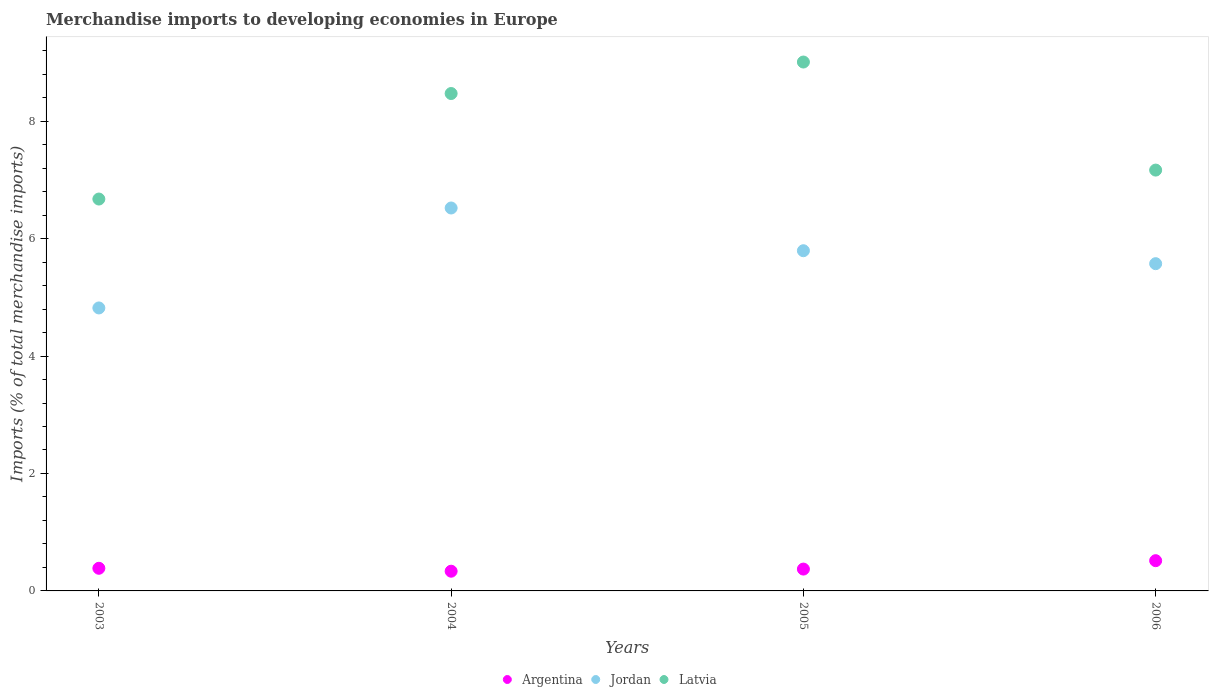What is the percentage total merchandise imports in Latvia in 2004?
Offer a very short reply. 8.47. Across all years, what is the maximum percentage total merchandise imports in Argentina?
Provide a short and direct response. 0.52. Across all years, what is the minimum percentage total merchandise imports in Argentina?
Offer a terse response. 0.34. In which year was the percentage total merchandise imports in Latvia maximum?
Your answer should be very brief. 2005. What is the total percentage total merchandise imports in Argentina in the graph?
Provide a succinct answer. 1.61. What is the difference between the percentage total merchandise imports in Jordan in 2004 and that in 2005?
Your answer should be very brief. 0.73. What is the difference between the percentage total merchandise imports in Argentina in 2004 and the percentage total merchandise imports in Jordan in 2005?
Offer a terse response. -5.46. What is the average percentage total merchandise imports in Latvia per year?
Provide a short and direct response. 7.83. In the year 2004, what is the difference between the percentage total merchandise imports in Latvia and percentage total merchandise imports in Jordan?
Your answer should be compact. 1.95. In how many years, is the percentage total merchandise imports in Latvia greater than 3.6 %?
Offer a very short reply. 4. What is the ratio of the percentage total merchandise imports in Argentina in 2004 to that in 2006?
Give a very brief answer. 0.65. Is the difference between the percentage total merchandise imports in Latvia in 2003 and 2005 greater than the difference between the percentage total merchandise imports in Jordan in 2003 and 2005?
Offer a terse response. No. What is the difference between the highest and the second highest percentage total merchandise imports in Argentina?
Make the answer very short. 0.13. What is the difference between the highest and the lowest percentage total merchandise imports in Jordan?
Keep it short and to the point. 1.7. Does the percentage total merchandise imports in Jordan monotonically increase over the years?
Your answer should be compact. No. Is the percentage total merchandise imports in Argentina strictly greater than the percentage total merchandise imports in Latvia over the years?
Keep it short and to the point. No. Is the percentage total merchandise imports in Jordan strictly less than the percentage total merchandise imports in Argentina over the years?
Provide a short and direct response. No. How many dotlines are there?
Make the answer very short. 3. How many years are there in the graph?
Offer a terse response. 4. What is the difference between two consecutive major ticks on the Y-axis?
Make the answer very short. 2. Are the values on the major ticks of Y-axis written in scientific E-notation?
Offer a terse response. No. Where does the legend appear in the graph?
Offer a terse response. Bottom center. How are the legend labels stacked?
Provide a succinct answer. Horizontal. What is the title of the graph?
Provide a succinct answer. Merchandise imports to developing economies in Europe. Does "Fiji" appear as one of the legend labels in the graph?
Offer a terse response. No. What is the label or title of the X-axis?
Make the answer very short. Years. What is the label or title of the Y-axis?
Make the answer very short. Imports (% of total merchandise imports). What is the Imports (% of total merchandise imports) in Argentina in 2003?
Give a very brief answer. 0.39. What is the Imports (% of total merchandise imports) in Jordan in 2003?
Your answer should be very brief. 4.82. What is the Imports (% of total merchandise imports) in Latvia in 2003?
Provide a succinct answer. 6.67. What is the Imports (% of total merchandise imports) of Argentina in 2004?
Keep it short and to the point. 0.34. What is the Imports (% of total merchandise imports) of Jordan in 2004?
Ensure brevity in your answer.  6.52. What is the Imports (% of total merchandise imports) of Latvia in 2004?
Provide a succinct answer. 8.47. What is the Imports (% of total merchandise imports) in Argentina in 2005?
Make the answer very short. 0.37. What is the Imports (% of total merchandise imports) of Jordan in 2005?
Your response must be concise. 5.79. What is the Imports (% of total merchandise imports) of Latvia in 2005?
Your response must be concise. 9.01. What is the Imports (% of total merchandise imports) in Argentina in 2006?
Provide a succinct answer. 0.52. What is the Imports (% of total merchandise imports) in Jordan in 2006?
Make the answer very short. 5.57. What is the Imports (% of total merchandise imports) in Latvia in 2006?
Ensure brevity in your answer.  7.17. Across all years, what is the maximum Imports (% of total merchandise imports) in Argentina?
Your answer should be compact. 0.52. Across all years, what is the maximum Imports (% of total merchandise imports) of Jordan?
Provide a short and direct response. 6.52. Across all years, what is the maximum Imports (% of total merchandise imports) of Latvia?
Give a very brief answer. 9.01. Across all years, what is the minimum Imports (% of total merchandise imports) in Argentina?
Give a very brief answer. 0.34. Across all years, what is the minimum Imports (% of total merchandise imports) of Jordan?
Give a very brief answer. 4.82. Across all years, what is the minimum Imports (% of total merchandise imports) of Latvia?
Give a very brief answer. 6.67. What is the total Imports (% of total merchandise imports) in Argentina in the graph?
Keep it short and to the point. 1.61. What is the total Imports (% of total merchandise imports) in Jordan in the graph?
Keep it short and to the point. 22.71. What is the total Imports (% of total merchandise imports) of Latvia in the graph?
Ensure brevity in your answer.  31.32. What is the difference between the Imports (% of total merchandise imports) of Argentina in 2003 and that in 2004?
Offer a very short reply. 0.05. What is the difference between the Imports (% of total merchandise imports) of Jordan in 2003 and that in 2004?
Provide a succinct answer. -1.7. What is the difference between the Imports (% of total merchandise imports) in Latvia in 2003 and that in 2004?
Offer a terse response. -1.8. What is the difference between the Imports (% of total merchandise imports) of Argentina in 2003 and that in 2005?
Ensure brevity in your answer.  0.01. What is the difference between the Imports (% of total merchandise imports) in Jordan in 2003 and that in 2005?
Make the answer very short. -0.97. What is the difference between the Imports (% of total merchandise imports) of Latvia in 2003 and that in 2005?
Give a very brief answer. -2.33. What is the difference between the Imports (% of total merchandise imports) in Argentina in 2003 and that in 2006?
Give a very brief answer. -0.13. What is the difference between the Imports (% of total merchandise imports) of Jordan in 2003 and that in 2006?
Give a very brief answer. -0.75. What is the difference between the Imports (% of total merchandise imports) of Latvia in 2003 and that in 2006?
Make the answer very short. -0.49. What is the difference between the Imports (% of total merchandise imports) of Argentina in 2004 and that in 2005?
Provide a succinct answer. -0.04. What is the difference between the Imports (% of total merchandise imports) in Jordan in 2004 and that in 2005?
Your response must be concise. 0.73. What is the difference between the Imports (% of total merchandise imports) of Latvia in 2004 and that in 2005?
Your answer should be very brief. -0.54. What is the difference between the Imports (% of total merchandise imports) of Argentina in 2004 and that in 2006?
Offer a very short reply. -0.18. What is the difference between the Imports (% of total merchandise imports) of Jordan in 2004 and that in 2006?
Offer a terse response. 0.95. What is the difference between the Imports (% of total merchandise imports) of Latvia in 2004 and that in 2006?
Give a very brief answer. 1.3. What is the difference between the Imports (% of total merchandise imports) in Argentina in 2005 and that in 2006?
Your response must be concise. -0.14. What is the difference between the Imports (% of total merchandise imports) of Jordan in 2005 and that in 2006?
Your answer should be very brief. 0.22. What is the difference between the Imports (% of total merchandise imports) of Latvia in 2005 and that in 2006?
Offer a very short reply. 1.84. What is the difference between the Imports (% of total merchandise imports) of Argentina in 2003 and the Imports (% of total merchandise imports) of Jordan in 2004?
Provide a short and direct response. -6.14. What is the difference between the Imports (% of total merchandise imports) in Argentina in 2003 and the Imports (% of total merchandise imports) in Latvia in 2004?
Your answer should be very brief. -8.09. What is the difference between the Imports (% of total merchandise imports) in Jordan in 2003 and the Imports (% of total merchandise imports) in Latvia in 2004?
Your response must be concise. -3.65. What is the difference between the Imports (% of total merchandise imports) in Argentina in 2003 and the Imports (% of total merchandise imports) in Jordan in 2005?
Offer a very short reply. -5.41. What is the difference between the Imports (% of total merchandise imports) of Argentina in 2003 and the Imports (% of total merchandise imports) of Latvia in 2005?
Keep it short and to the point. -8.62. What is the difference between the Imports (% of total merchandise imports) of Jordan in 2003 and the Imports (% of total merchandise imports) of Latvia in 2005?
Offer a very short reply. -4.19. What is the difference between the Imports (% of total merchandise imports) in Argentina in 2003 and the Imports (% of total merchandise imports) in Jordan in 2006?
Your response must be concise. -5.19. What is the difference between the Imports (% of total merchandise imports) in Argentina in 2003 and the Imports (% of total merchandise imports) in Latvia in 2006?
Provide a short and direct response. -6.78. What is the difference between the Imports (% of total merchandise imports) of Jordan in 2003 and the Imports (% of total merchandise imports) of Latvia in 2006?
Provide a succinct answer. -2.35. What is the difference between the Imports (% of total merchandise imports) in Argentina in 2004 and the Imports (% of total merchandise imports) in Jordan in 2005?
Offer a terse response. -5.46. What is the difference between the Imports (% of total merchandise imports) of Argentina in 2004 and the Imports (% of total merchandise imports) of Latvia in 2005?
Make the answer very short. -8.67. What is the difference between the Imports (% of total merchandise imports) of Jordan in 2004 and the Imports (% of total merchandise imports) of Latvia in 2005?
Provide a succinct answer. -2.49. What is the difference between the Imports (% of total merchandise imports) in Argentina in 2004 and the Imports (% of total merchandise imports) in Jordan in 2006?
Ensure brevity in your answer.  -5.24. What is the difference between the Imports (% of total merchandise imports) of Argentina in 2004 and the Imports (% of total merchandise imports) of Latvia in 2006?
Provide a succinct answer. -6.83. What is the difference between the Imports (% of total merchandise imports) of Jordan in 2004 and the Imports (% of total merchandise imports) of Latvia in 2006?
Offer a very short reply. -0.65. What is the difference between the Imports (% of total merchandise imports) in Argentina in 2005 and the Imports (% of total merchandise imports) in Jordan in 2006?
Keep it short and to the point. -5.2. What is the difference between the Imports (% of total merchandise imports) in Argentina in 2005 and the Imports (% of total merchandise imports) in Latvia in 2006?
Make the answer very short. -6.8. What is the difference between the Imports (% of total merchandise imports) in Jordan in 2005 and the Imports (% of total merchandise imports) in Latvia in 2006?
Your answer should be very brief. -1.37. What is the average Imports (% of total merchandise imports) in Argentina per year?
Offer a terse response. 0.4. What is the average Imports (% of total merchandise imports) of Jordan per year?
Make the answer very short. 5.68. What is the average Imports (% of total merchandise imports) in Latvia per year?
Make the answer very short. 7.83. In the year 2003, what is the difference between the Imports (% of total merchandise imports) of Argentina and Imports (% of total merchandise imports) of Jordan?
Provide a short and direct response. -4.43. In the year 2003, what is the difference between the Imports (% of total merchandise imports) of Argentina and Imports (% of total merchandise imports) of Latvia?
Offer a terse response. -6.29. In the year 2003, what is the difference between the Imports (% of total merchandise imports) in Jordan and Imports (% of total merchandise imports) in Latvia?
Your response must be concise. -1.85. In the year 2004, what is the difference between the Imports (% of total merchandise imports) of Argentina and Imports (% of total merchandise imports) of Jordan?
Your response must be concise. -6.19. In the year 2004, what is the difference between the Imports (% of total merchandise imports) in Argentina and Imports (% of total merchandise imports) in Latvia?
Make the answer very short. -8.14. In the year 2004, what is the difference between the Imports (% of total merchandise imports) of Jordan and Imports (% of total merchandise imports) of Latvia?
Your response must be concise. -1.95. In the year 2005, what is the difference between the Imports (% of total merchandise imports) of Argentina and Imports (% of total merchandise imports) of Jordan?
Your response must be concise. -5.42. In the year 2005, what is the difference between the Imports (% of total merchandise imports) of Argentina and Imports (% of total merchandise imports) of Latvia?
Your response must be concise. -8.64. In the year 2005, what is the difference between the Imports (% of total merchandise imports) of Jordan and Imports (% of total merchandise imports) of Latvia?
Make the answer very short. -3.21. In the year 2006, what is the difference between the Imports (% of total merchandise imports) in Argentina and Imports (% of total merchandise imports) in Jordan?
Make the answer very short. -5.06. In the year 2006, what is the difference between the Imports (% of total merchandise imports) in Argentina and Imports (% of total merchandise imports) in Latvia?
Provide a succinct answer. -6.65. In the year 2006, what is the difference between the Imports (% of total merchandise imports) of Jordan and Imports (% of total merchandise imports) of Latvia?
Ensure brevity in your answer.  -1.59. What is the ratio of the Imports (% of total merchandise imports) of Argentina in 2003 to that in 2004?
Your answer should be compact. 1.15. What is the ratio of the Imports (% of total merchandise imports) in Jordan in 2003 to that in 2004?
Keep it short and to the point. 0.74. What is the ratio of the Imports (% of total merchandise imports) of Latvia in 2003 to that in 2004?
Keep it short and to the point. 0.79. What is the ratio of the Imports (% of total merchandise imports) in Argentina in 2003 to that in 2005?
Your response must be concise. 1.04. What is the ratio of the Imports (% of total merchandise imports) of Jordan in 2003 to that in 2005?
Keep it short and to the point. 0.83. What is the ratio of the Imports (% of total merchandise imports) of Latvia in 2003 to that in 2005?
Make the answer very short. 0.74. What is the ratio of the Imports (% of total merchandise imports) of Argentina in 2003 to that in 2006?
Keep it short and to the point. 0.75. What is the ratio of the Imports (% of total merchandise imports) of Jordan in 2003 to that in 2006?
Give a very brief answer. 0.86. What is the ratio of the Imports (% of total merchandise imports) in Latvia in 2003 to that in 2006?
Your response must be concise. 0.93. What is the ratio of the Imports (% of total merchandise imports) of Argentina in 2004 to that in 2005?
Provide a succinct answer. 0.9. What is the ratio of the Imports (% of total merchandise imports) of Jordan in 2004 to that in 2005?
Provide a short and direct response. 1.13. What is the ratio of the Imports (% of total merchandise imports) in Latvia in 2004 to that in 2005?
Ensure brevity in your answer.  0.94. What is the ratio of the Imports (% of total merchandise imports) of Argentina in 2004 to that in 2006?
Offer a terse response. 0.65. What is the ratio of the Imports (% of total merchandise imports) in Jordan in 2004 to that in 2006?
Your answer should be compact. 1.17. What is the ratio of the Imports (% of total merchandise imports) of Latvia in 2004 to that in 2006?
Your answer should be compact. 1.18. What is the ratio of the Imports (% of total merchandise imports) in Argentina in 2005 to that in 2006?
Your response must be concise. 0.72. What is the ratio of the Imports (% of total merchandise imports) of Jordan in 2005 to that in 2006?
Make the answer very short. 1.04. What is the ratio of the Imports (% of total merchandise imports) of Latvia in 2005 to that in 2006?
Your response must be concise. 1.26. What is the difference between the highest and the second highest Imports (% of total merchandise imports) in Argentina?
Your answer should be compact. 0.13. What is the difference between the highest and the second highest Imports (% of total merchandise imports) of Jordan?
Offer a very short reply. 0.73. What is the difference between the highest and the second highest Imports (% of total merchandise imports) in Latvia?
Make the answer very short. 0.54. What is the difference between the highest and the lowest Imports (% of total merchandise imports) of Argentina?
Keep it short and to the point. 0.18. What is the difference between the highest and the lowest Imports (% of total merchandise imports) of Jordan?
Your response must be concise. 1.7. What is the difference between the highest and the lowest Imports (% of total merchandise imports) of Latvia?
Ensure brevity in your answer.  2.33. 